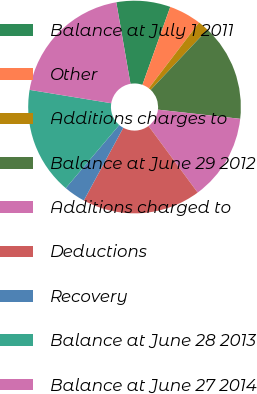<chart> <loc_0><loc_0><loc_500><loc_500><pie_chart><fcel>Balance at July 1 2011<fcel>Other<fcel>Additions charges to<fcel>Balance at June 29 2012<fcel>Additions charged to<fcel>Deductions<fcel>Recovery<fcel>Balance at June 28 2013<fcel>Balance at June 27 2014<nl><fcel>8.2%<fcel>4.92%<fcel>1.64%<fcel>14.75%<fcel>13.11%<fcel>18.03%<fcel>3.28%<fcel>16.39%<fcel>19.67%<nl></chart> 